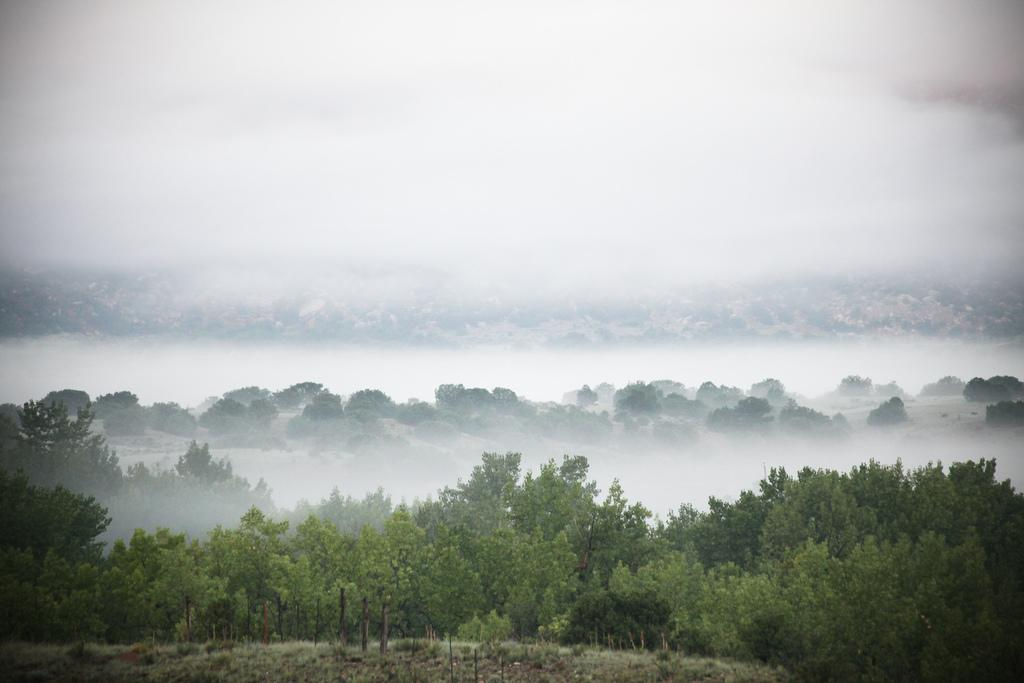What type of vegetation can be seen in the image? There are trees in the image. What atmospheric condition is visible in the image? There is fog visible in the image. Where is the drawer located in the image? There is no drawer present in the image. Can you see any arguments taking place in the image? There is no indication of any arguments in the image. What type of muscle can be seen in the image? There is no muscle visible in the image. 